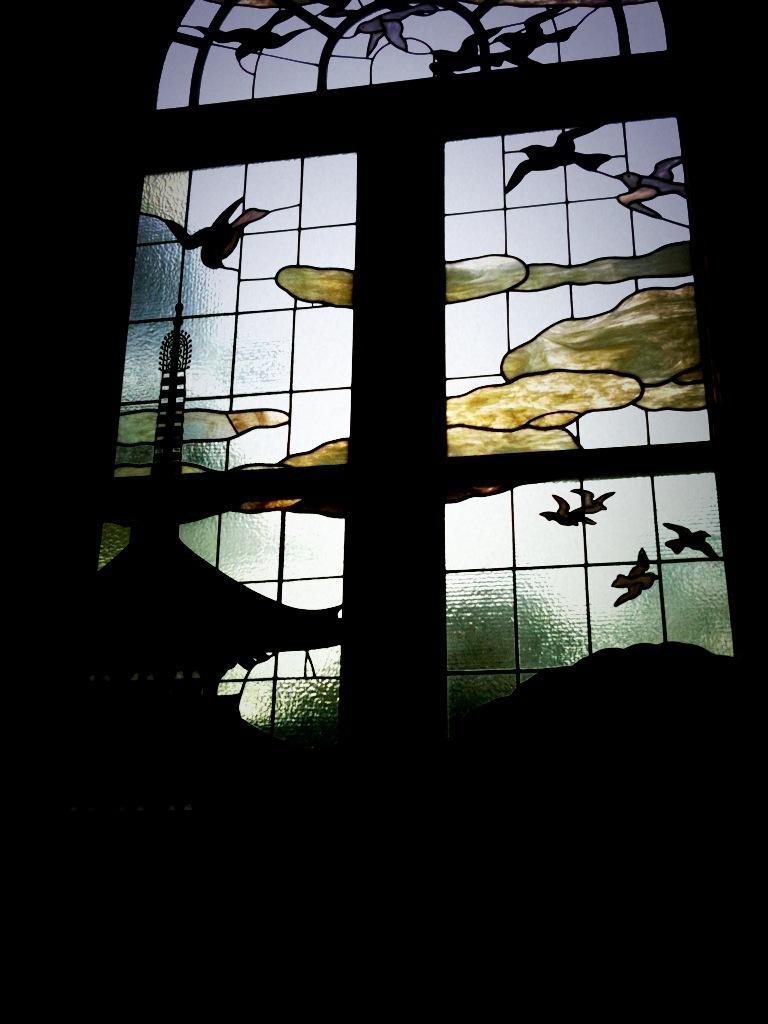How would you summarize this image in a sentence or two? In this picture I can see designer glass window and I can see dark background. 